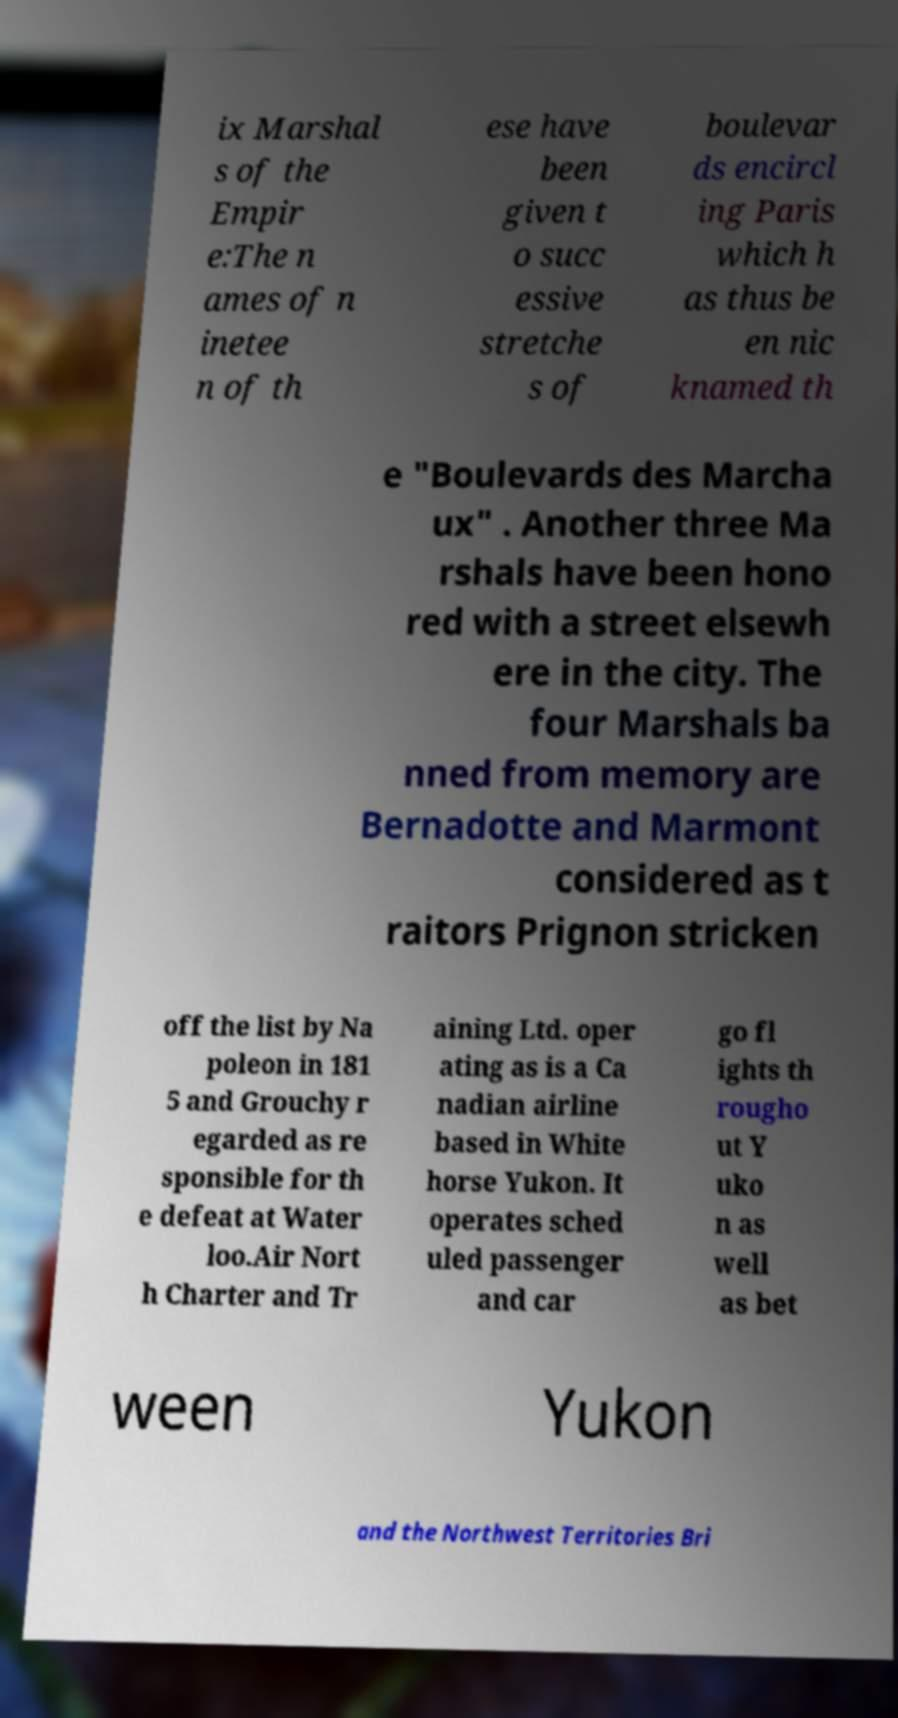I need the written content from this picture converted into text. Can you do that? ix Marshal s of the Empir e:The n ames of n inetee n of th ese have been given t o succ essive stretche s of boulevar ds encircl ing Paris which h as thus be en nic knamed th e "Boulevards des Marcha ux" . Another three Ma rshals have been hono red with a street elsewh ere in the city. The four Marshals ba nned from memory are Bernadotte and Marmont considered as t raitors Prignon stricken off the list by Na poleon in 181 5 and Grouchy r egarded as re sponsible for th e defeat at Water loo.Air Nort h Charter and Tr aining Ltd. oper ating as is a Ca nadian airline based in White horse Yukon. It operates sched uled passenger and car go fl ights th rougho ut Y uko n as well as bet ween Yukon and the Northwest Territories Bri 